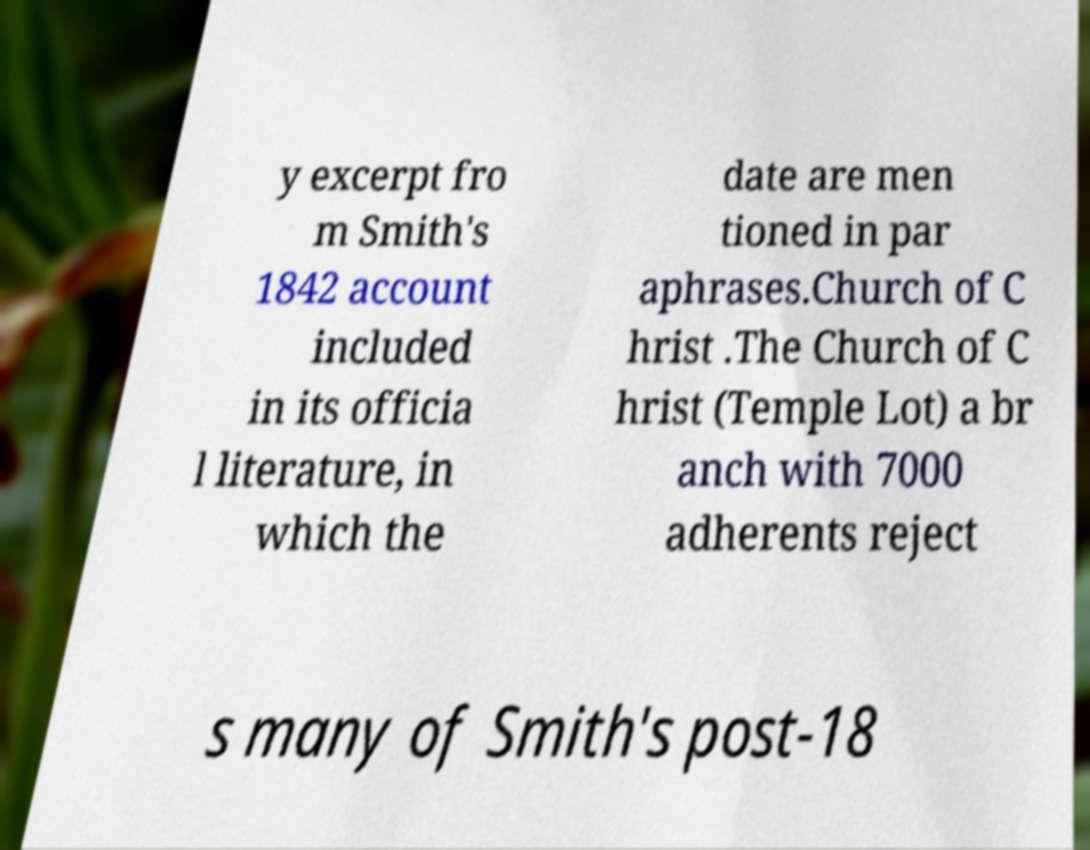For documentation purposes, I need the text within this image transcribed. Could you provide that? y excerpt fro m Smith's 1842 account included in its officia l literature, in which the date are men tioned in par aphrases.Church of C hrist .The Church of C hrist (Temple Lot) a br anch with 7000 adherents reject s many of Smith's post-18 